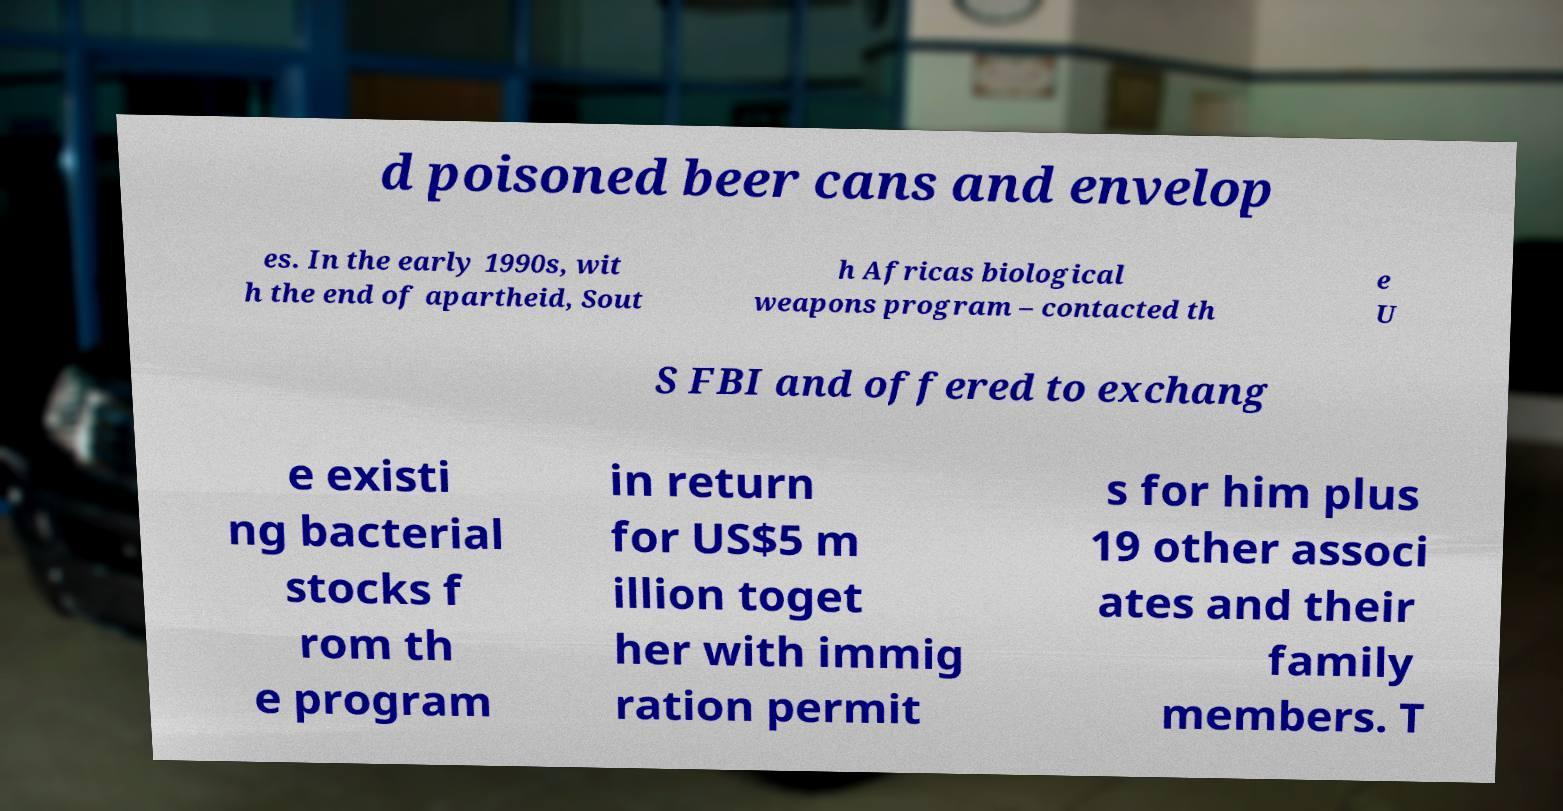Could you extract and type out the text from this image? d poisoned beer cans and envelop es. In the early 1990s, wit h the end of apartheid, Sout h Africas biological weapons program – contacted th e U S FBI and offered to exchang e existi ng bacterial stocks f rom th e program in return for US$5 m illion toget her with immig ration permit s for him plus 19 other associ ates and their family members. T 